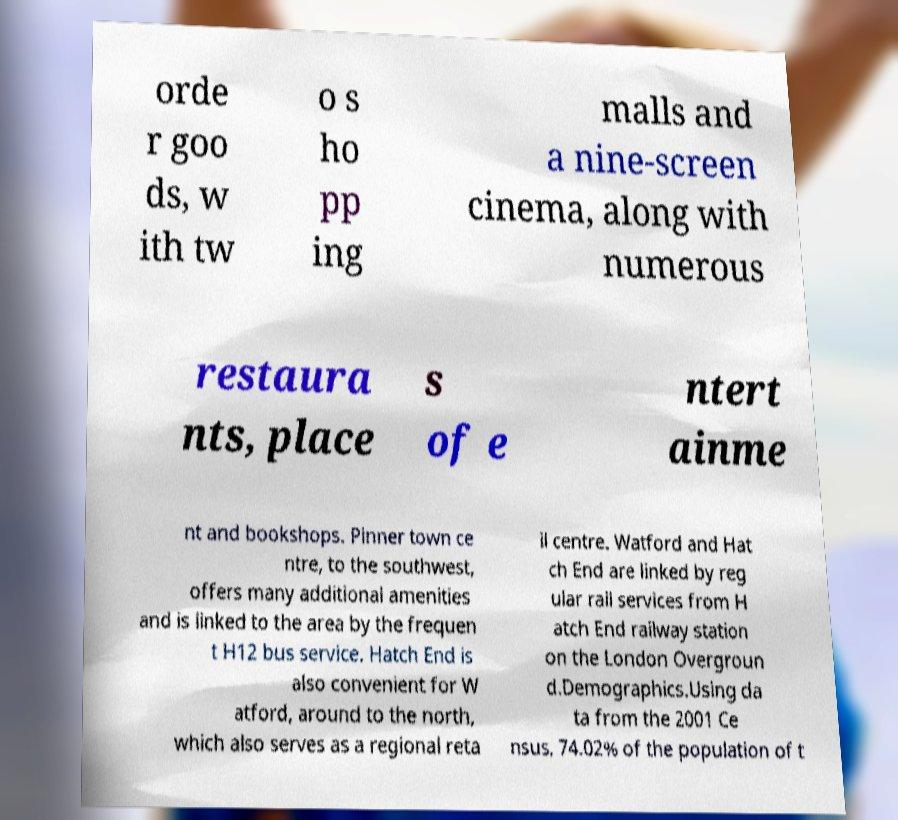Could you assist in decoding the text presented in this image and type it out clearly? orde r goo ds, w ith tw o s ho pp ing malls and a nine-screen cinema, along with numerous restaura nts, place s of e ntert ainme nt and bookshops. Pinner town ce ntre, to the southwest, offers many additional amenities and is linked to the area by the frequen t H12 bus service. Hatch End is also convenient for W atford, around to the north, which also serves as a regional reta il centre. Watford and Hat ch End are linked by reg ular rail services from H atch End railway station on the London Overgroun d.Demographics.Using da ta from the 2001 Ce nsus, 74.02% of the population of t 